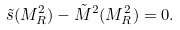Convert formula to latex. <formula><loc_0><loc_0><loc_500><loc_500>\tilde { s } ( M _ { R } ^ { 2 } ) - \tilde { M } ^ { 2 } ( M _ { R } ^ { 2 } ) = 0 .</formula> 